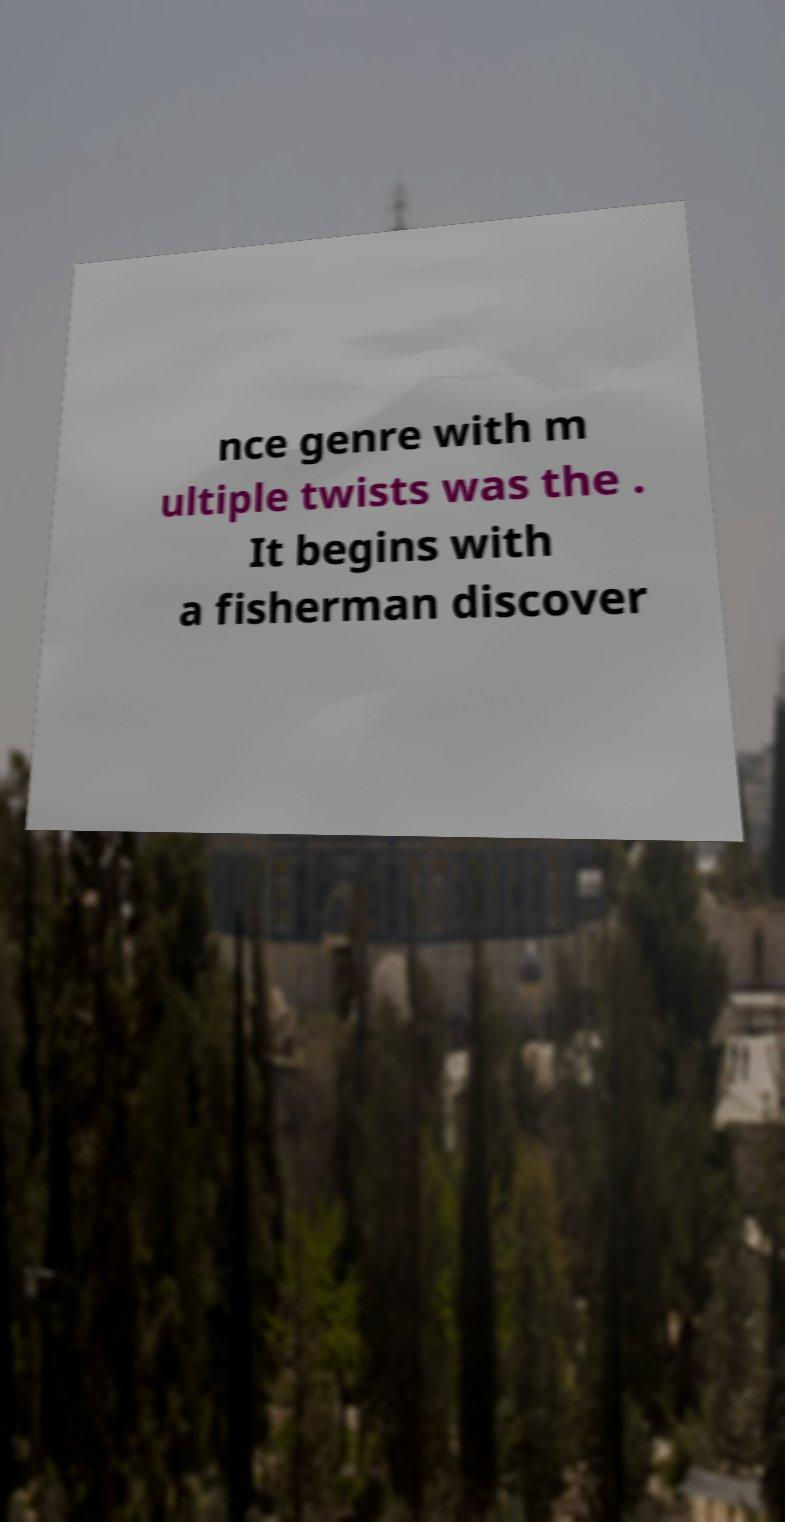I need the written content from this picture converted into text. Can you do that? nce genre with m ultiple twists was the . It begins with a fisherman discover 